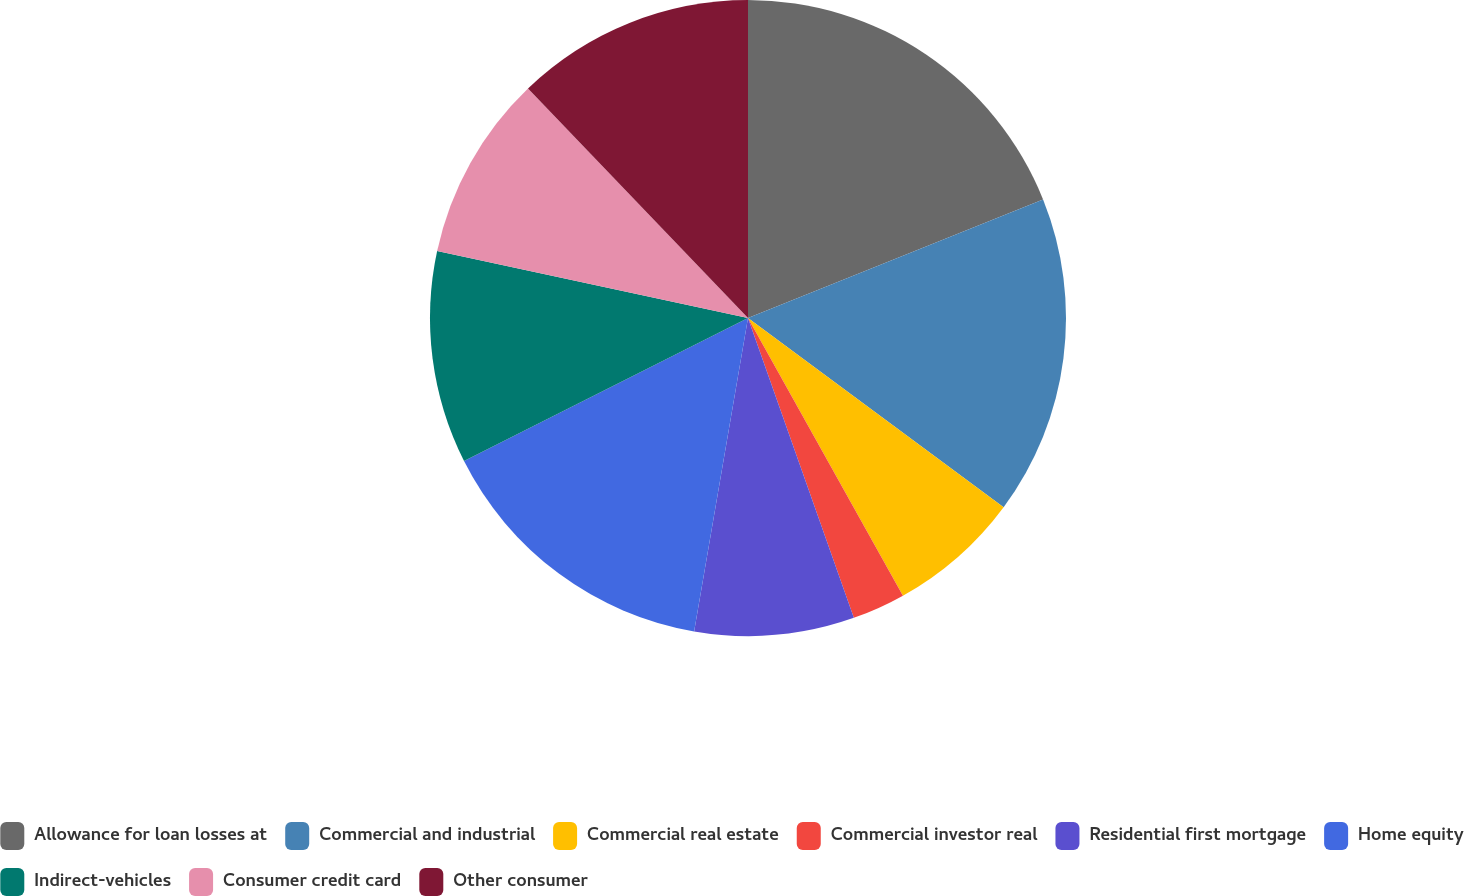Convert chart to OTSL. <chart><loc_0><loc_0><loc_500><loc_500><pie_chart><fcel>Allowance for loan losses at<fcel>Commercial and industrial<fcel>Commercial real estate<fcel>Commercial investor real<fcel>Residential first mortgage<fcel>Home equity<fcel>Indirect-vehicles<fcel>Consumer credit card<fcel>Other consumer<nl><fcel>18.92%<fcel>16.22%<fcel>6.76%<fcel>2.7%<fcel>8.11%<fcel>14.86%<fcel>10.81%<fcel>9.46%<fcel>12.16%<nl></chart> 